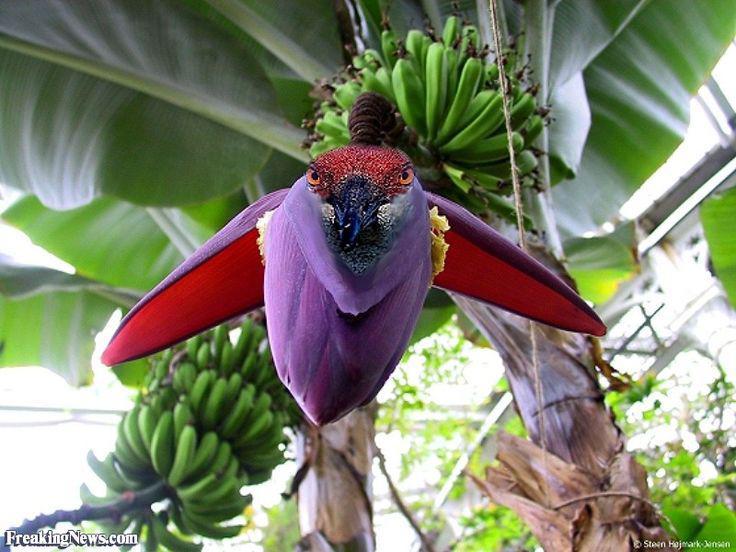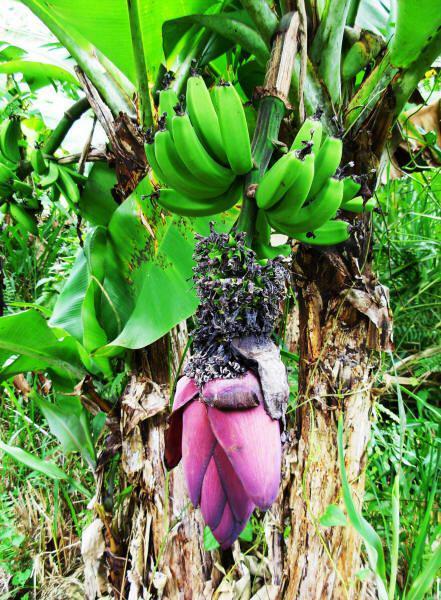The first image is the image on the left, the second image is the image on the right. For the images displayed, is the sentence "In the image to the right, the banana flower is purple." factually correct? Answer yes or no. Yes. 